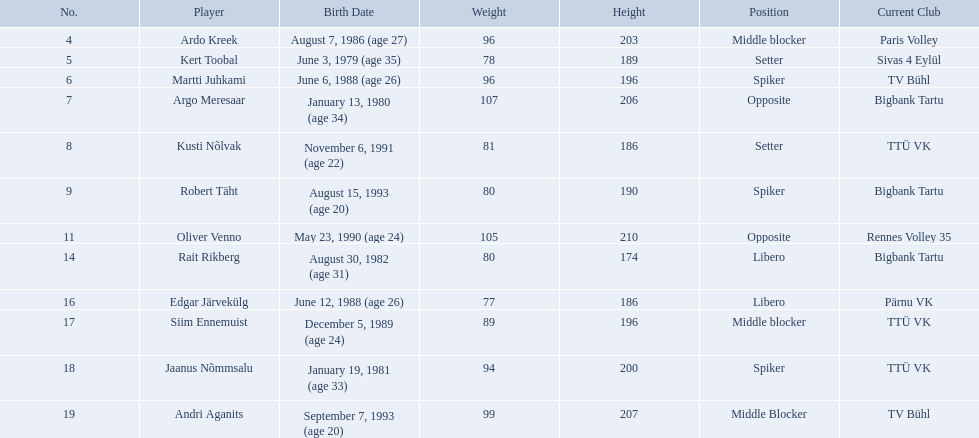What are the heights in cm of the men on the team? 203, 189, 196, 206, 186, 190, 210, 174, 186, 196, 200, 207. What is the tallest height of a team member? 210. Which player stands at 210? Oliver Venno. What are the elevations in centimeters of the guys on the crew? 203, 189, 196, 206, 186, 190, 210, 174, 186, 196, 200, 207. What is the top elevation of a crew member? 210. Which athlete is 210 tall? Oliver Venno. Can you list all the players? Ardo Kreek, Kert Toobal, Martti Juhkami, Argo Meresaar, Kusti Nõlvak, Robert Täht, Oliver Venno, Rait Rikberg, Edgar Järvekülg, Siim Ennemuist, Jaanus Nõmmsalu, Andri Aganits. What are their respective heights? 203, 189, 196, 206, 186, 190, 210, 174, 186, 196, 200, 207. And who stands the tallest? Oliver Venno. Who are the members of the team? Ardo Kreek, Kert Toobal, Martti Juhkami, Argo Meresaar, Kusti Nõlvak, Robert Täht, Oliver Venno, Rait Rikberg, Edgar Järvekülg, Siim Ennemuist, Jaanus Nõmmsalu, Andri Aganits. What are their individual heights? 203, 189, 196, 206, 186, 190, 210, 174, 186, 196, 200, 207. And which one is the tallest player? Oliver Venno. How tall are the men on the team in centimeters? 203, 189, 196, 206, 186, 190, 210, 174, 186, 196, 200, 207. Who is the tallest member of the team? 210. Which individual has a height of 210 cm? Oliver Venno. 